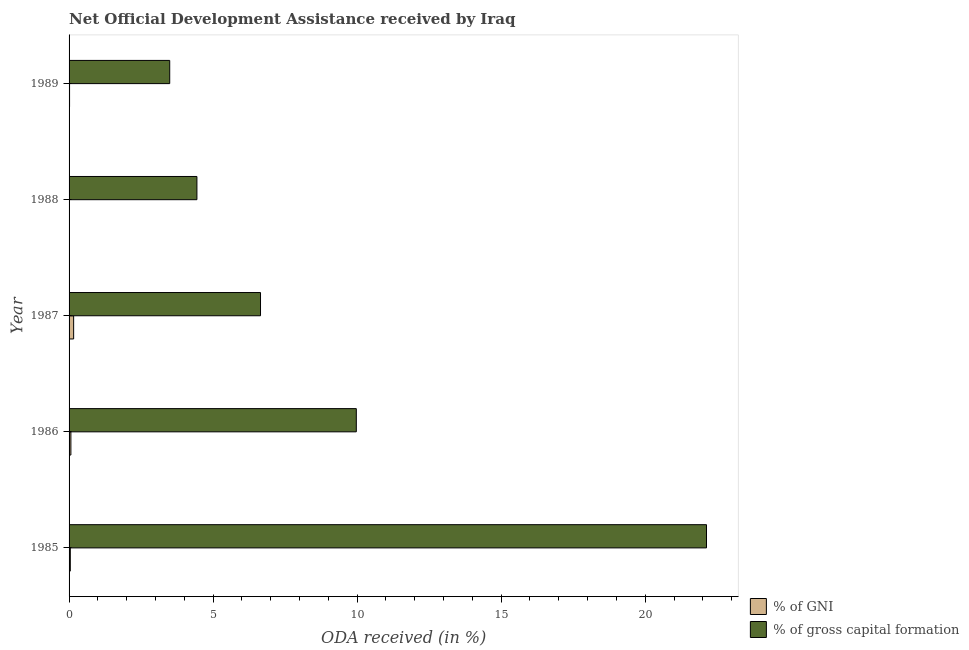How many different coloured bars are there?
Make the answer very short. 2. Are the number of bars per tick equal to the number of legend labels?
Offer a very short reply. Yes. Are the number of bars on each tick of the Y-axis equal?
Your answer should be very brief. Yes. How many bars are there on the 4th tick from the bottom?
Offer a very short reply. 2. What is the label of the 4th group of bars from the top?
Your answer should be very brief. 1986. In how many cases, is the number of bars for a given year not equal to the number of legend labels?
Provide a succinct answer. 0. What is the oda received as percentage of gni in 1989?
Give a very brief answer. 0.02. Across all years, what is the maximum oda received as percentage of gross capital formation?
Keep it short and to the point. 22.13. Across all years, what is the minimum oda received as percentage of gni?
Offer a very short reply. 0.01. In which year was the oda received as percentage of gni maximum?
Offer a terse response. 1987. What is the total oda received as percentage of gross capital formation in the graph?
Keep it short and to the point. 46.68. What is the difference between the oda received as percentage of gni in 1985 and that in 1986?
Give a very brief answer. -0.02. What is the difference between the oda received as percentage of gross capital formation in 1989 and the oda received as percentage of gni in 1985?
Ensure brevity in your answer.  3.45. What is the average oda received as percentage of gross capital formation per year?
Offer a terse response. 9.34. In the year 1989, what is the difference between the oda received as percentage of gni and oda received as percentage of gross capital formation?
Your answer should be compact. -3.48. In how many years, is the oda received as percentage of gni greater than 11 %?
Provide a short and direct response. 0. What is the ratio of the oda received as percentage of gross capital formation in 1985 to that in 1987?
Offer a very short reply. 3.33. What is the difference between the highest and the second highest oda received as percentage of gni?
Provide a short and direct response. 0.1. What is the difference between the highest and the lowest oda received as percentage of gni?
Your answer should be very brief. 0.15. Is the sum of the oda received as percentage of gni in 1987 and 1989 greater than the maximum oda received as percentage of gross capital formation across all years?
Your answer should be very brief. No. What does the 1st bar from the top in 1989 represents?
Provide a short and direct response. % of gross capital formation. What does the 1st bar from the bottom in 1987 represents?
Your answer should be very brief. % of GNI. Are all the bars in the graph horizontal?
Give a very brief answer. Yes. What is the difference between two consecutive major ticks on the X-axis?
Your answer should be very brief. 5. What is the title of the graph?
Keep it short and to the point. Net Official Development Assistance received by Iraq. Does "Methane" appear as one of the legend labels in the graph?
Ensure brevity in your answer.  No. What is the label or title of the X-axis?
Ensure brevity in your answer.  ODA received (in %). What is the ODA received (in %) in % of GNI in 1985?
Give a very brief answer. 0.04. What is the ODA received (in %) in % of gross capital formation in 1985?
Provide a succinct answer. 22.13. What is the ODA received (in %) of % of GNI in 1986?
Give a very brief answer. 0.06. What is the ODA received (in %) of % of gross capital formation in 1986?
Provide a succinct answer. 9.97. What is the ODA received (in %) of % of GNI in 1987?
Keep it short and to the point. 0.16. What is the ODA received (in %) of % of gross capital formation in 1987?
Provide a succinct answer. 6.65. What is the ODA received (in %) of % of GNI in 1988?
Your response must be concise. 0.01. What is the ODA received (in %) of % of gross capital formation in 1988?
Your response must be concise. 4.44. What is the ODA received (in %) of % of GNI in 1989?
Offer a very short reply. 0.02. What is the ODA received (in %) in % of gross capital formation in 1989?
Offer a very short reply. 3.49. Across all years, what is the maximum ODA received (in %) in % of GNI?
Make the answer very short. 0.16. Across all years, what is the maximum ODA received (in %) of % of gross capital formation?
Provide a short and direct response. 22.13. Across all years, what is the minimum ODA received (in %) in % of GNI?
Provide a short and direct response. 0.01. Across all years, what is the minimum ODA received (in %) of % of gross capital formation?
Give a very brief answer. 3.49. What is the total ODA received (in %) of % of GNI in the graph?
Provide a succinct answer. 0.29. What is the total ODA received (in %) in % of gross capital formation in the graph?
Provide a short and direct response. 46.68. What is the difference between the ODA received (in %) of % of GNI in 1985 and that in 1986?
Provide a succinct answer. -0.02. What is the difference between the ODA received (in %) of % of gross capital formation in 1985 and that in 1986?
Ensure brevity in your answer.  12.16. What is the difference between the ODA received (in %) of % of GNI in 1985 and that in 1987?
Provide a short and direct response. -0.12. What is the difference between the ODA received (in %) of % of gross capital formation in 1985 and that in 1987?
Offer a terse response. 15.48. What is the difference between the ODA received (in %) in % of GNI in 1985 and that in 1988?
Make the answer very short. 0.03. What is the difference between the ODA received (in %) of % of gross capital formation in 1985 and that in 1988?
Offer a terse response. 17.69. What is the difference between the ODA received (in %) in % of GNI in 1985 and that in 1989?
Make the answer very short. 0.03. What is the difference between the ODA received (in %) in % of gross capital formation in 1985 and that in 1989?
Your answer should be compact. 18.63. What is the difference between the ODA received (in %) of % of GNI in 1986 and that in 1987?
Your answer should be compact. -0.1. What is the difference between the ODA received (in %) of % of gross capital formation in 1986 and that in 1987?
Provide a succinct answer. 3.33. What is the difference between the ODA received (in %) of % of GNI in 1986 and that in 1988?
Keep it short and to the point. 0.05. What is the difference between the ODA received (in %) of % of gross capital formation in 1986 and that in 1988?
Provide a succinct answer. 5.53. What is the difference between the ODA received (in %) in % of GNI in 1986 and that in 1989?
Your answer should be compact. 0.05. What is the difference between the ODA received (in %) in % of gross capital formation in 1986 and that in 1989?
Give a very brief answer. 6.48. What is the difference between the ODA received (in %) in % of GNI in 1987 and that in 1988?
Offer a very short reply. 0.15. What is the difference between the ODA received (in %) in % of gross capital formation in 1987 and that in 1988?
Provide a succinct answer. 2.21. What is the difference between the ODA received (in %) in % of GNI in 1987 and that in 1989?
Make the answer very short. 0.14. What is the difference between the ODA received (in %) of % of gross capital formation in 1987 and that in 1989?
Make the answer very short. 3.15. What is the difference between the ODA received (in %) of % of GNI in 1988 and that in 1989?
Make the answer very short. -0.01. What is the difference between the ODA received (in %) of % of gross capital formation in 1988 and that in 1989?
Give a very brief answer. 0.94. What is the difference between the ODA received (in %) in % of GNI in 1985 and the ODA received (in %) in % of gross capital formation in 1986?
Provide a succinct answer. -9.93. What is the difference between the ODA received (in %) in % of GNI in 1985 and the ODA received (in %) in % of gross capital formation in 1987?
Your answer should be very brief. -6.6. What is the difference between the ODA received (in %) in % of GNI in 1985 and the ODA received (in %) in % of gross capital formation in 1988?
Your answer should be very brief. -4.39. What is the difference between the ODA received (in %) in % of GNI in 1985 and the ODA received (in %) in % of gross capital formation in 1989?
Give a very brief answer. -3.45. What is the difference between the ODA received (in %) in % of GNI in 1986 and the ODA received (in %) in % of gross capital formation in 1987?
Your response must be concise. -6.58. What is the difference between the ODA received (in %) of % of GNI in 1986 and the ODA received (in %) of % of gross capital formation in 1988?
Make the answer very short. -4.38. What is the difference between the ODA received (in %) in % of GNI in 1986 and the ODA received (in %) in % of gross capital formation in 1989?
Keep it short and to the point. -3.43. What is the difference between the ODA received (in %) of % of GNI in 1987 and the ODA received (in %) of % of gross capital formation in 1988?
Keep it short and to the point. -4.28. What is the difference between the ODA received (in %) of % of GNI in 1987 and the ODA received (in %) of % of gross capital formation in 1989?
Your answer should be compact. -3.33. What is the difference between the ODA received (in %) of % of GNI in 1988 and the ODA received (in %) of % of gross capital formation in 1989?
Provide a short and direct response. -3.48. What is the average ODA received (in %) in % of GNI per year?
Your response must be concise. 0.06. What is the average ODA received (in %) in % of gross capital formation per year?
Ensure brevity in your answer.  9.34. In the year 1985, what is the difference between the ODA received (in %) in % of GNI and ODA received (in %) in % of gross capital formation?
Offer a terse response. -22.08. In the year 1986, what is the difference between the ODA received (in %) in % of GNI and ODA received (in %) in % of gross capital formation?
Give a very brief answer. -9.91. In the year 1987, what is the difference between the ODA received (in %) of % of GNI and ODA received (in %) of % of gross capital formation?
Make the answer very short. -6.49. In the year 1988, what is the difference between the ODA received (in %) of % of GNI and ODA received (in %) of % of gross capital formation?
Provide a succinct answer. -4.43. In the year 1989, what is the difference between the ODA received (in %) in % of GNI and ODA received (in %) in % of gross capital formation?
Provide a succinct answer. -3.48. What is the ratio of the ODA received (in %) in % of GNI in 1985 to that in 1986?
Offer a very short reply. 0.69. What is the ratio of the ODA received (in %) of % of gross capital formation in 1985 to that in 1986?
Your response must be concise. 2.22. What is the ratio of the ODA received (in %) of % of GNI in 1985 to that in 1987?
Keep it short and to the point. 0.27. What is the ratio of the ODA received (in %) of % of gross capital formation in 1985 to that in 1987?
Give a very brief answer. 3.33. What is the ratio of the ODA received (in %) of % of GNI in 1985 to that in 1988?
Make the answer very short. 4.01. What is the ratio of the ODA received (in %) of % of gross capital formation in 1985 to that in 1988?
Provide a succinct answer. 4.99. What is the ratio of the ODA received (in %) in % of GNI in 1985 to that in 1989?
Your response must be concise. 2.52. What is the ratio of the ODA received (in %) in % of gross capital formation in 1985 to that in 1989?
Offer a very short reply. 6.33. What is the ratio of the ODA received (in %) in % of GNI in 1986 to that in 1987?
Your answer should be compact. 0.4. What is the ratio of the ODA received (in %) of % of gross capital formation in 1986 to that in 1987?
Your answer should be very brief. 1.5. What is the ratio of the ODA received (in %) in % of GNI in 1986 to that in 1988?
Your response must be concise. 5.84. What is the ratio of the ODA received (in %) of % of gross capital formation in 1986 to that in 1988?
Make the answer very short. 2.25. What is the ratio of the ODA received (in %) in % of GNI in 1986 to that in 1989?
Your answer should be very brief. 3.67. What is the ratio of the ODA received (in %) in % of gross capital formation in 1986 to that in 1989?
Keep it short and to the point. 2.85. What is the ratio of the ODA received (in %) of % of GNI in 1987 to that in 1988?
Make the answer very short. 14.73. What is the ratio of the ODA received (in %) in % of gross capital formation in 1987 to that in 1988?
Your response must be concise. 1.5. What is the ratio of the ODA received (in %) in % of GNI in 1987 to that in 1989?
Your answer should be very brief. 9.27. What is the ratio of the ODA received (in %) in % of gross capital formation in 1987 to that in 1989?
Ensure brevity in your answer.  1.9. What is the ratio of the ODA received (in %) in % of GNI in 1988 to that in 1989?
Make the answer very short. 0.63. What is the ratio of the ODA received (in %) in % of gross capital formation in 1988 to that in 1989?
Provide a succinct answer. 1.27. What is the difference between the highest and the second highest ODA received (in %) of % of GNI?
Keep it short and to the point. 0.1. What is the difference between the highest and the second highest ODA received (in %) in % of gross capital formation?
Your response must be concise. 12.16. What is the difference between the highest and the lowest ODA received (in %) in % of GNI?
Your answer should be compact. 0.15. What is the difference between the highest and the lowest ODA received (in %) of % of gross capital formation?
Your answer should be compact. 18.63. 